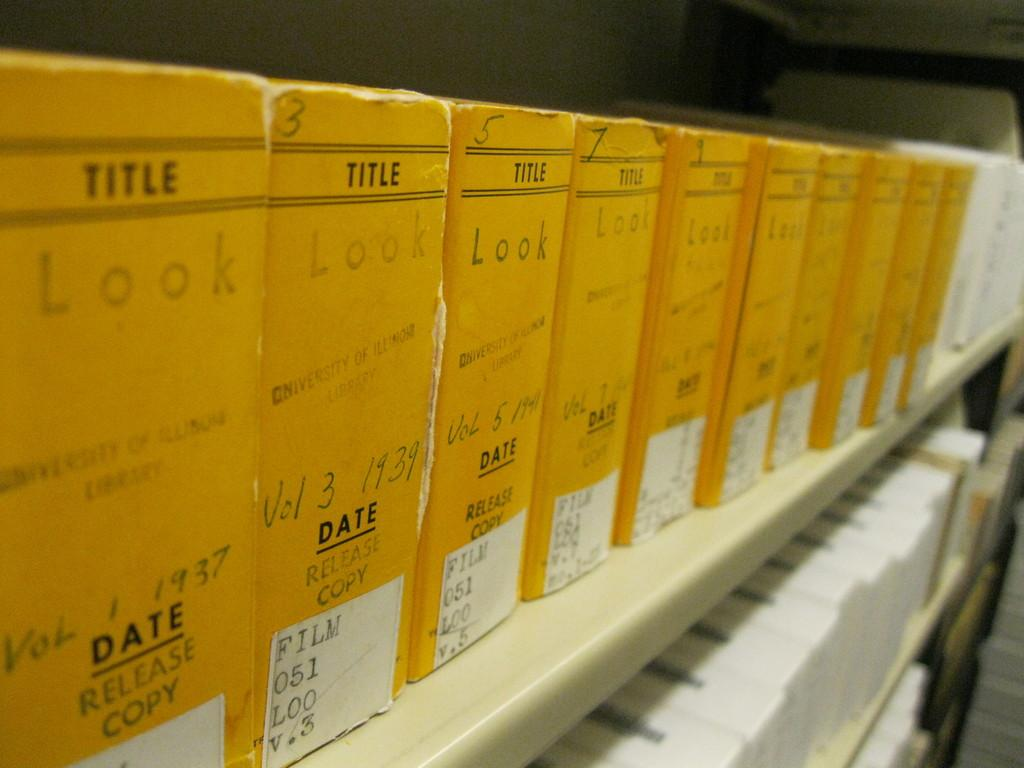<image>
Provide a brief description of the given image. A line of yellow boxes of films on a shelf with the title and dates. 